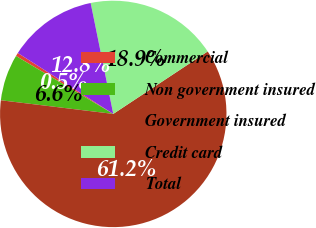Convert chart to OTSL. <chart><loc_0><loc_0><loc_500><loc_500><pie_chart><fcel>Commercial<fcel>Non government insured<fcel>Government insured<fcel>Credit card<fcel>Total<nl><fcel>0.49%<fcel>6.63%<fcel>61.23%<fcel>18.9%<fcel>12.76%<nl></chart> 